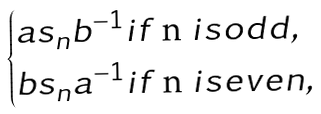Convert formula to latex. <formula><loc_0><loc_0><loc_500><loc_500>\begin{cases} a s _ { n } b ^ { - 1 } i f $ n $ i s o d d , \\ b s _ { n } a ^ { - 1 } i f $ n $ i s e v e n , \end{cases}</formula> 